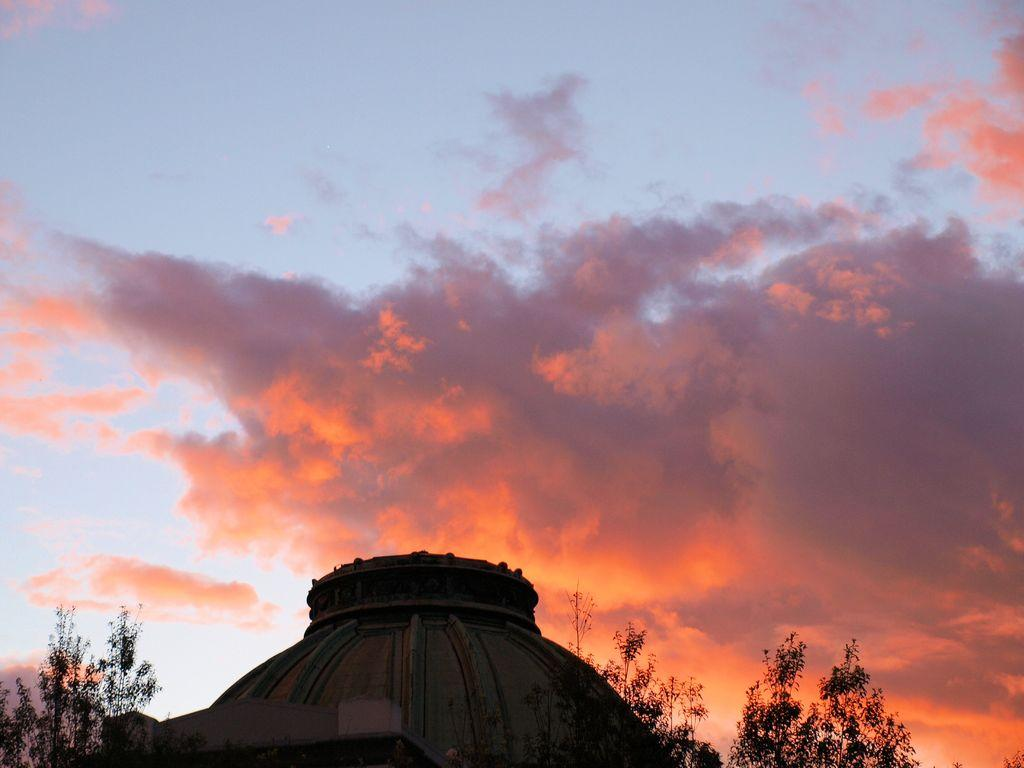What is the main subject of the image? The main subject of the image is the top of a building. Are there any natural elements visible in the image? Yes, there are trees near the building. What can be seen in the background of the image? The sky is visible in the background of the image. What is the condition of the sky in the image? Clouds are present in the sky. What type of quartz can be seen embedded in the building's facade in the image? There is no quartz visible in the image; it only shows the top of the building and trees nearby. Can you tell me what advice your uncle gave about the building in the image? There is no mention of an uncle or any advice in the image or the provided facts. 